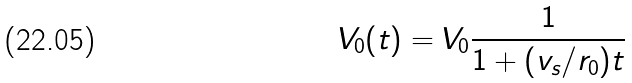<formula> <loc_0><loc_0><loc_500><loc_500>V _ { 0 } ( t ) = V _ { 0 } \frac { 1 } { 1 + ( v _ { s } / r _ { 0 } ) t }</formula> 